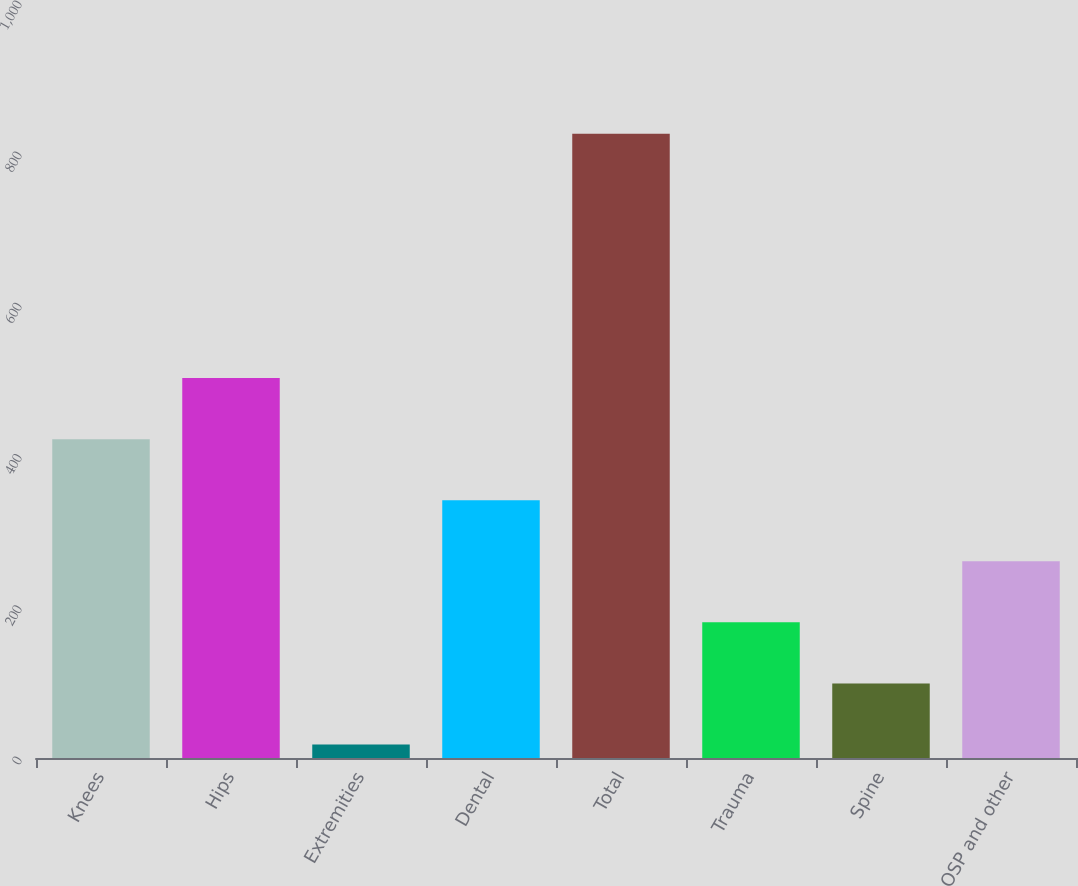Convert chart. <chart><loc_0><loc_0><loc_500><loc_500><bar_chart><fcel>Knees<fcel>Hips<fcel>Extremities<fcel>Dental<fcel>Total<fcel>Trauma<fcel>Spine<fcel>OSP and other<nl><fcel>421.75<fcel>502.52<fcel>17.9<fcel>340.98<fcel>825.6<fcel>179.44<fcel>98.67<fcel>260.21<nl></chart> 